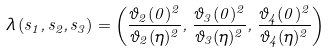<formula> <loc_0><loc_0><loc_500><loc_500>\lambda \, ( s _ { 1 } , s _ { 2 } , s _ { 3 } ) = \left ( \frac { \vartheta _ { 2 } ( 0 ) ^ { 2 } } { \vartheta _ { 2 } ( \eta ) ^ { 2 } } , \, \frac { \vartheta _ { 3 } ( 0 ) ^ { 2 } } { \vartheta _ { 3 } ( \eta ) ^ { 2 } } , \, \frac { \vartheta _ { 4 } ( 0 ) ^ { 2 } } { \vartheta _ { 4 } ( \eta ) ^ { 2 } } \right )</formula> 